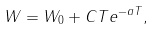<formula> <loc_0><loc_0><loc_500><loc_500>W = W _ { 0 } + C T e ^ { - a T } ,</formula> 